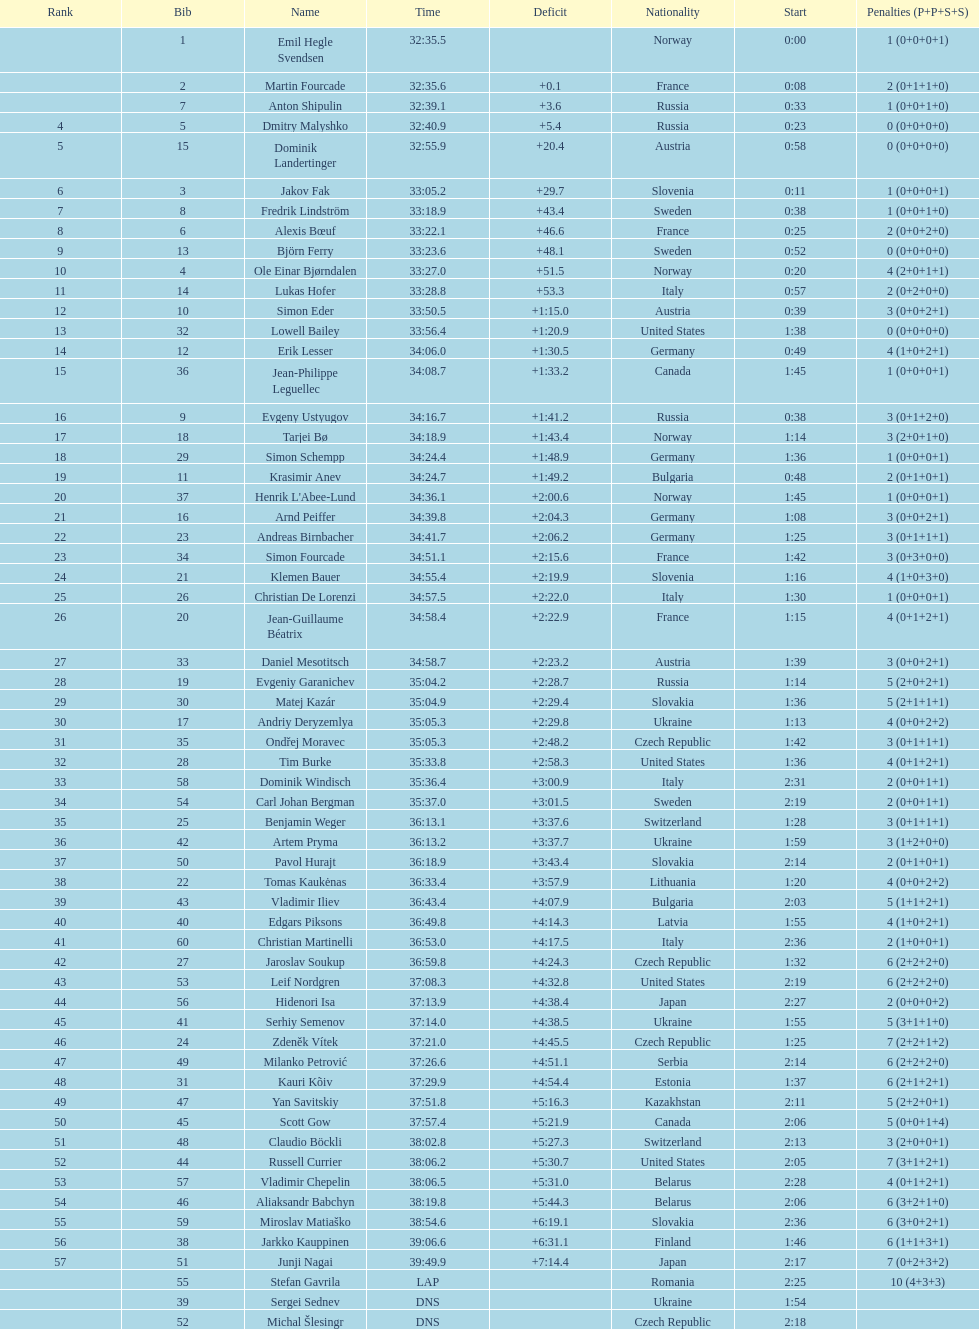How many united states participants failed to secure medals? 4. 